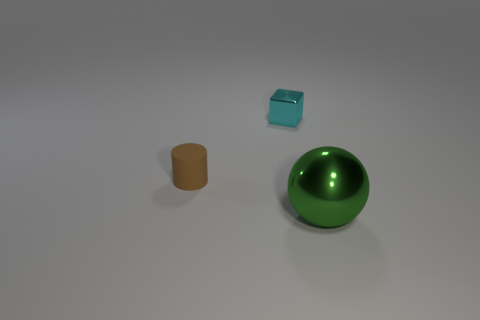Add 1 big blue matte blocks. How many objects exist? 4 Subtract all cylinders. How many objects are left? 2 Subtract 0 blue spheres. How many objects are left? 3 Subtract 1 balls. How many balls are left? 0 Subtract all cyan cylinders. Subtract all yellow balls. How many cylinders are left? 1 Subtract all green metallic objects. Subtract all green metallic balls. How many objects are left? 1 Add 2 tiny rubber cylinders. How many tiny rubber cylinders are left? 3 Add 2 blocks. How many blocks exist? 3 